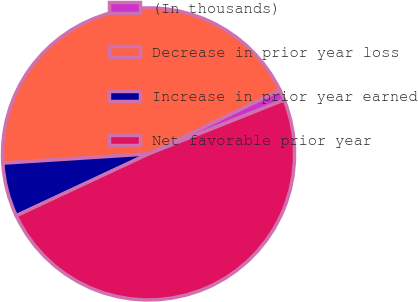<chart> <loc_0><loc_0><loc_500><loc_500><pie_chart><fcel>(In thousands)<fcel>Decrease in prior year loss<fcel>Increase in prior year earned<fcel>Net favorable prior year<nl><fcel>1.16%<fcel>43.81%<fcel>5.95%<fcel>49.07%<nl></chart> 